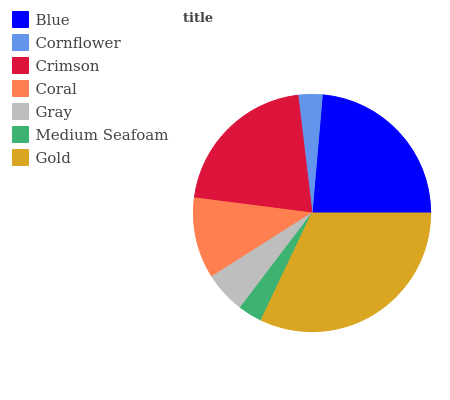Is Medium Seafoam the minimum?
Answer yes or no. Yes. Is Gold the maximum?
Answer yes or no. Yes. Is Cornflower the minimum?
Answer yes or no. No. Is Cornflower the maximum?
Answer yes or no. No. Is Blue greater than Cornflower?
Answer yes or no. Yes. Is Cornflower less than Blue?
Answer yes or no. Yes. Is Cornflower greater than Blue?
Answer yes or no. No. Is Blue less than Cornflower?
Answer yes or no. No. Is Coral the high median?
Answer yes or no. Yes. Is Coral the low median?
Answer yes or no. Yes. Is Cornflower the high median?
Answer yes or no. No. Is Gray the low median?
Answer yes or no. No. 